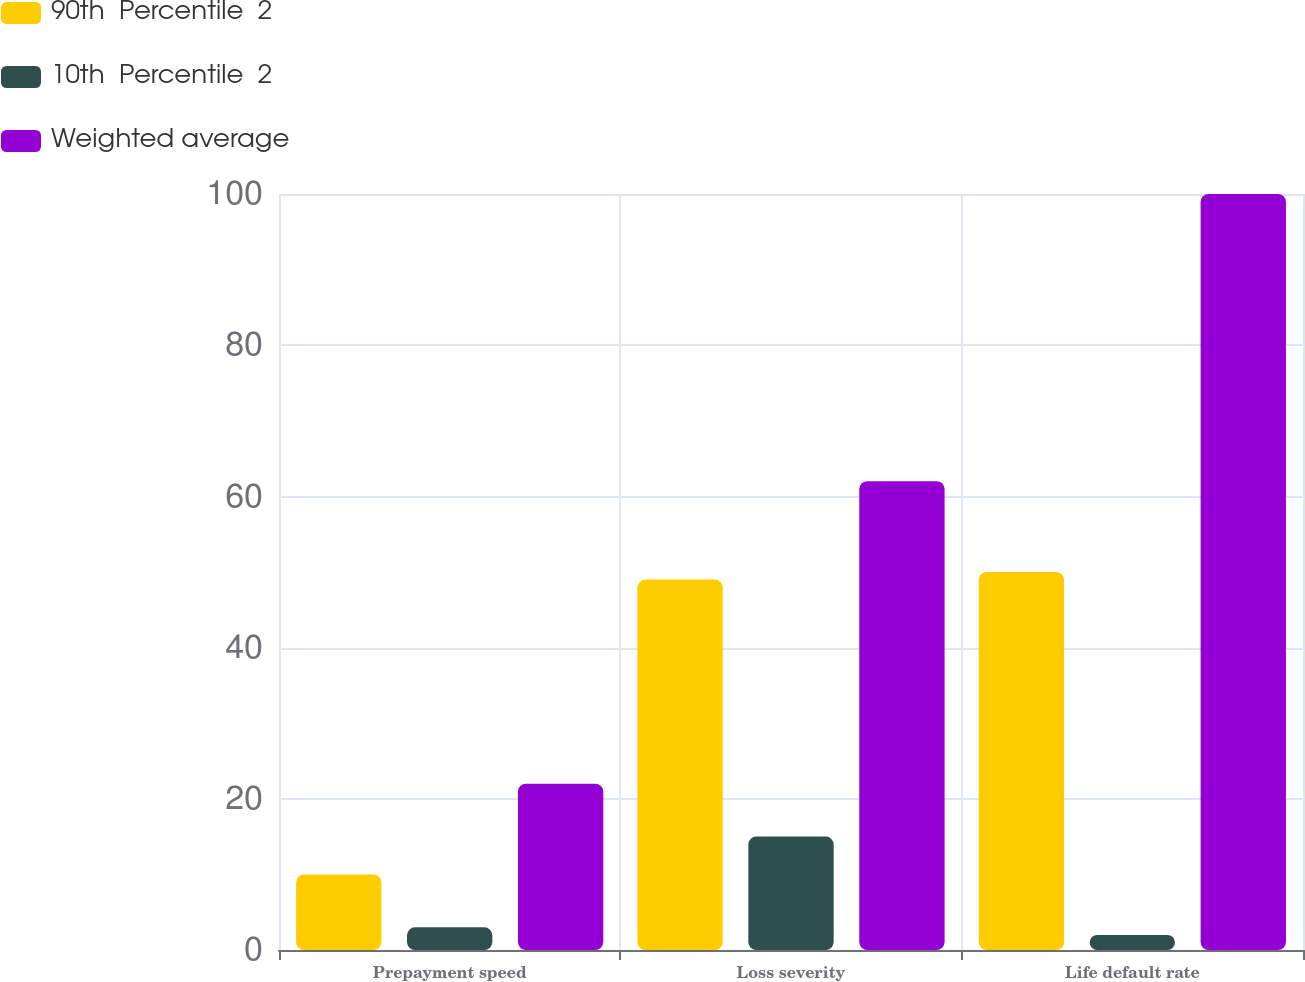Convert chart. <chart><loc_0><loc_0><loc_500><loc_500><stacked_bar_chart><ecel><fcel>Prepayment speed<fcel>Loss severity<fcel>Life default rate<nl><fcel>90th  Percentile  2<fcel>10<fcel>49<fcel>50<nl><fcel>10th  Percentile  2<fcel>3<fcel>15<fcel>2<nl><fcel>Weighted average<fcel>22<fcel>62<fcel>100<nl></chart> 